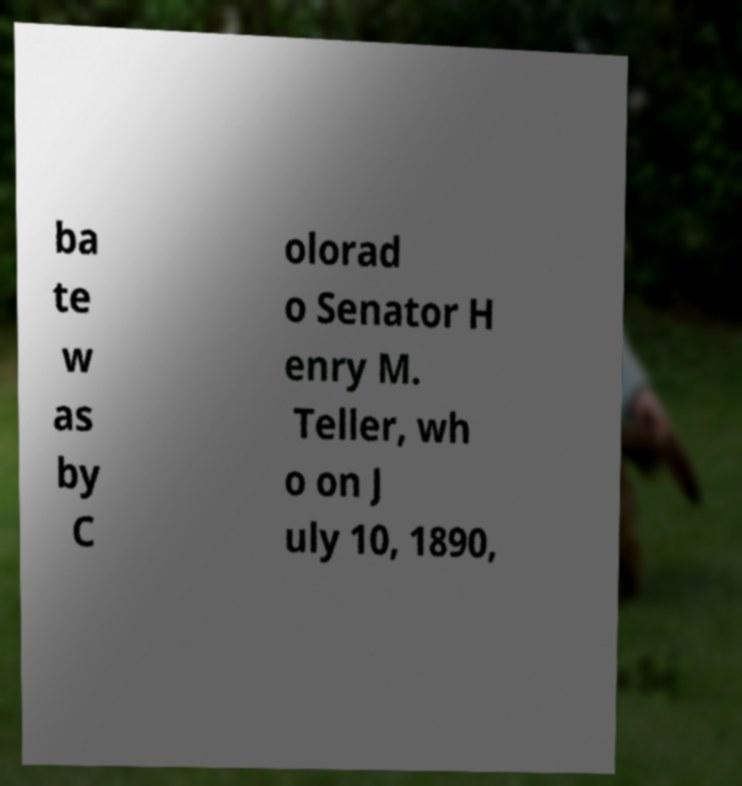Can you accurately transcribe the text from the provided image for me? ba te w as by C olorad o Senator H enry M. Teller, wh o on J uly 10, 1890, 